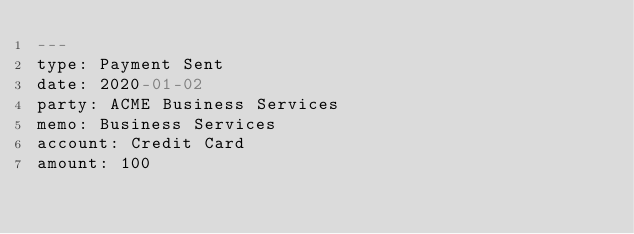<code> <loc_0><loc_0><loc_500><loc_500><_YAML_>---
type: Payment Sent
date: 2020-01-02
party: ACME Business Services 
memo: Business Services
account: Credit Card
amount: 100
</code> 